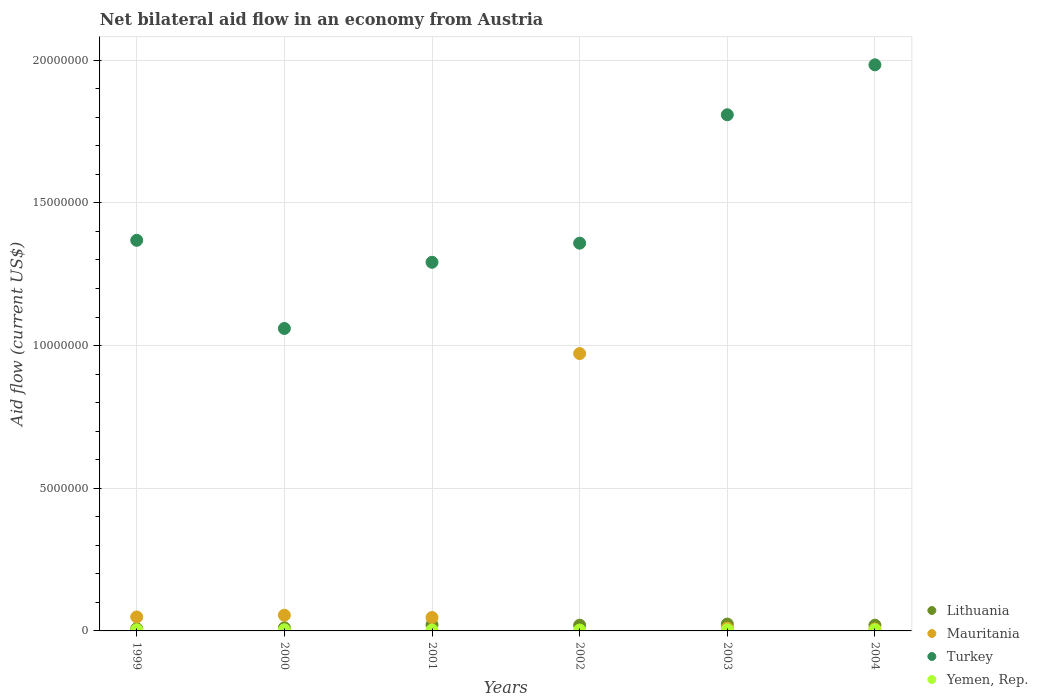How many different coloured dotlines are there?
Keep it short and to the point. 4. Is the number of dotlines equal to the number of legend labels?
Keep it short and to the point. Yes. What is the net bilateral aid flow in Mauritania in 2002?
Your answer should be compact. 9.72e+06. In which year was the net bilateral aid flow in Mauritania maximum?
Your answer should be very brief. 2002. What is the total net bilateral aid flow in Turkey in the graph?
Your answer should be compact. 8.87e+07. What is the difference between the net bilateral aid flow in Turkey in 2000 and that in 2004?
Make the answer very short. -9.24e+06. What is the difference between the net bilateral aid flow in Yemen, Rep. in 2002 and the net bilateral aid flow in Turkey in 1999?
Your answer should be compact. -1.37e+07. What is the average net bilateral aid flow in Turkey per year?
Ensure brevity in your answer.  1.48e+07. In the year 1999, what is the difference between the net bilateral aid flow in Lithuania and net bilateral aid flow in Yemen, Rep.?
Your answer should be compact. 4.00e+04. What is the ratio of the net bilateral aid flow in Turkey in 1999 to that in 2000?
Offer a very short reply. 1.29. Is the net bilateral aid flow in Yemen, Rep. in 1999 less than that in 2000?
Keep it short and to the point. No. What is the difference between the highest and the lowest net bilateral aid flow in Turkey?
Offer a very short reply. 9.24e+06. In how many years, is the net bilateral aid flow in Yemen, Rep. greater than the average net bilateral aid flow in Yemen, Rep. taken over all years?
Make the answer very short. 4. Is the sum of the net bilateral aid flow in Lithuania in 2002 and 2004 greater than the maximum net bilateral aid flow in Mauritania across all years?
Give a very brief answer. No. Is it the case that in every year, the sum of the net bilateral aid flow in Yemen, Rep. and net bilateral aid flow in Lithuania  is greater than the net bilateral aid flow in Mauritania?
Give a very brief answer. No. Does the net bilateral aid flow in Lithuania monotonically increase over the years?
Give a very brief answer. No. How many dotlines are there?
Offer a terse response. 4. Are the values on the major ticks of Y-axis written in scientific E-notation?
Offer a terse response. No. Where does the legend appear in the graph?
Offer a very short reply. Bottom right. How many legend labels are there?
Your answer should be compact. 4. How are the legend labels stacked?
Your answer should be compact. Vertical. What is the title of the graph?
Make the answer very short. Net bilateral aid flow in an economy from Austria. What is the label or title of the X-axis?
Provide a succinct answer. Years. What is the Aid flow (current US$) of Turkey in 1999?
Your answer should be very brief. 1.37e+07. What is the Aid flow (current US$) in Lithuania in 2000?
Ensure brevity in your answer.  1.10e+05. What is the Aid flow (current US$) in Mauritania in 2000?
Ensure brevity in your answer.  5.50e+05. What is the Aid flow (current US$) of Turkey in 2000?
Offer a very short reply. 1.06e+07. What is the Aid flow (current US$) of Yemen, Rep. in 2000?
Keep it short and to the point. 4.00e+04. What is the Aid flow (current US$) of Lithuania in 2001?
Your response must be concise. 2.20e+05. What is the Aid flow (current US$) of Mauritania in 2001?
Provide a succinct answer. 4.70e+05. What is the Aid flow (current US$) in Turkey in 2001?
Give a very brief answer. 1.29e+07. What is the Aid flow (current US$) in Mauritania in 2002?
Offer a terse response. 9.72e+06. What is the Aid flow (current US$) in Turkey in 2002?
Ensure brevity in your answer.  1.36e+07. What is the Aid flow (current US$) in Yemen, Rep. in 2002?
Provide a short and direct response. 3.00e+04. What is the Aid flow (current US$) of Lithuania in 2003?
Your response must be concise. 2.40e+05. What is the Aid flow (current US$) of Turkey in 2003?
Provide a short and direct response. 1.81e+07. What is the Aid flow (current US$) of Yemen, Rep. in 2003?
Give a very brief answer. 4.00e+04. What is the Aid flow (current US$) in Lithuania in 2004?
Your answer should be very brief. 2.00e+05. What is the Aid flow (current US$) in Mauritania in 2004?
Provide a short and direct response. 7.00e+04. What is the Aid flow (current US$) in Turkey in 2004?
Offer a very short reply. 1.98e+07. What is the Aid flow (current US$) in Yemen, Rep. in 2004?
Ensure brevity in your answer.  4.00e+04. Across all years, what is the maximum Aid flow (current US$) in Lithuania?
Make the answer very short. 2.40e+05. Across all years, what is the maximum Aid flow (current US$) in Mauritania?
Provide a succinct answer. 9.72e+06. Across all years, what is the maximum Aid flow (current US$) in Turkey?
Your answer should be compact. 1.98e+07. Across all years, what is the minimum Aid flow (current US$) of Mauritania?
Offer a terse response. 7.00e+04. Across all years, what is the minimum Aid flow (current US$) in Turkey?
Keep it short and to the point. 1.06e+07. Across all years, what is the minimum Aid flow (current US$) in Yemen, Rep.?
Provide a short and direct response. 3.00e+04. What is the total Aid flow (current US$) of Lithuania in the graph?
Keep it short and to the point. 1.05e+06. What is the total Aid flow (current US$) of Mauritania in the graph?
Your answer should be compact. 1.14e+07. What is the total Aid flow (current US$) of Turkey in the graph?
Provide a succinct answer. 8.87e+07. What is the total Aid flow (current US$) of Yemen, Rep. in the graph?
Provide a short and direct response. 2.20e+05. What is the difference between the Aid flow (current US$) of Mauritania in 1999 and that in 2000?
Make the answer very short. -6.00e+04. What is the difference between the Aid flow (current US$) in Turkey in 1999 and that in 2000?
Your response must be concise. 3.09e+06. What is the difference between the Aid flow (current US$) of Yemen, Rep. in 1999 and that in 2000?
Your answer should be very brief. 0. What is the difference between the Aid flow (current US$) in Mauritania in 1999 and that in 2001?
Give a very brief answer. 2.00e+04. What is the difference between the Aid flow (current US$) of Turkey in 1999 and that in 2001?
Offer a terse response. 7.70e+05. What is the difference between the Aid flow (current US$) in Mauritania in 1999 and that in 2002?
Provide a succinct answer. -9.23e+06. What is the difference between the Aid flow (current US$) in Mauritania in 1999 and that in 2003?
Give a very brief answer. 3.90e+05. What is the difference between the Aid flow (current US$) of Turkey in 1999 and that in 2003?
Give a very brief answer. -4.40e+06. What is the difference between the Aid flow (current US$) of Mauritania in 1999 and that in 2004?
Your answer should be compact. 4.20e+05. What is the difference between the Aid flow (current US$) of Turkey in 1999 and that in 2004?
Make the answer very short. -6.15e+06. What is the difference between the Aid flow (current US$) in Yemen, Rep. in 1999 and that in 2004?
Offer a terse response. 0. What is the difference between the Aid flow (current US$) in Lithuania in 2000 and that in 2001?
Give a very brief answer. -1.10e+05. What is the difference between the Aid flow (current US$) in Mauritania in 2000 and that in 2001?
Offer a very short reply. 8.00e+04. What is the difference between the Aid flow (current US$) of Turkey in 2000 and that in 2001?
Offer a very short reply. -2.32e+06. What is the difference between the Aid flow (current US$) of Lithuania in 2000 and that in 2002?
Keep it short and to the point. -9.00e+04. What is the difference between the Aid flow (current US$) in Mauritania in 2000 and that in 2002?
Your answer should be very brief. -9.17e+06. What is the difference between the Aid flow (current US$) in Turkey in 2000 and that in 2002?
Provide a short and direct response. -2.99e+06. What is the difference between the Aid flow (current US$) of Lithuania in 2000 and that in 2003?
Keep it short and to the point. -1.30e+05. What is the difference between the Aid flow (current US$) of Turkey in 2000 and that in 2003?
Provide a succinct answer. -7.49e+06. What is the difference between the Aid flow (current US$) in Yemen, Rep. in 2000 and that in 2003?
Provide a short and direct response. 0. What is the difference between the Aid flow (current US$) of Lithuania in 2000 and that in 2004?
Keep it short and to the point. -9.00e+04. What is the difference between the Aid flow (current US$) in Turkey in 2000 and that in 2004?
Provide a short and direct response. -9.24e+06. What is the difference between the Aid flow (current US$) in Yemen, Rep. in 2000 and that in 2004?
Keep it short and to the point. 0. What is the difference between the Aid flow (current US$) in Lithuania in 2001 and that in 2002?
Ensure brevity in your answer.  2.00e+04. What is the difference between the Aid flow (current US$) in Mauritania in 2001 and that in 2002?
Offer a very short reply. -9.25e+06. What is the difference between the Aid flow (current US$) in Turkey in 2001 and that in 2002?
Ensure brevity in your answer.  -6.70e+05. What is the difference between the Aid flow (current US$) of Lithuania in 2001 and that in 2003?
Your answer should be very brief. -2.00e+04. What is the difference between the Aid flow (current US$) in Mauritania in 2001 and that in 2003?
Keep it short and to the point. 3.70e+05. What is the difference between the Aid flow (current US$) of Turkey in 2001 and that in 2003?
Keep it short and to the point. -5.17e+06. What is the difference between the Aid flow (current US$) of Mauritania in 2001 and that in 2004?
Your answer should be compact. 4.00e+05. What is the difference between the Aid flow (current US$) of Turkey in 2001 and that in 2004?
Provide a short and direct response. -6.92e+06. What is the difference between the Aid flow (current US$) in Yemen, Rep. in 2001 and that in 2004?
Your response must be concise. -10000. What is the difference between the Aid flow (current US$) of Lithuania in 2002 and that in 2003?
Provide a succinct answer. -4.00e+04. What is the difference between the Aid flow (current US$) in Mauritania in 2002 and that in 2003?
Offer a very short reply. 9.62e+06. What is the difference between the Aid flow (current US$) in Turkey in 2002 and that in 2003?
Provide a short and direct response. -4.50e+06. What is the difference between the Aid flow (current US$) in Yemen, Rep. in 2002 and that in 2003?
Give a very brief answer. -10000. What is the difference between the Aid flow (current US$) in Lithuania in 2002 and that in 2004?
Offer a terse response. 0. What is the difference between the Aid flow (current US$) in Mauritania in 2002 and that in 2004?
Offer a very short reply. 9.65e+06. What is the difference between the Aid flow (current US$) in Turkey in 2002 and that in 2004?
Your answer should be compact. -6.25e+06. What is the difference between the Aid flow (current US$) in Yemen, Rep. in 2002 and that in 2004?
Your response must be concise. -10000. What is the difference between the Aid flow (current US$) in Turkey in 2003 and that in 2004?
Give a very brief answer. -1.75e+06. What is the difference between the Aid flow (current US$) of Yemen, Rep. in 2003 and that in 2004?
Offer a terse response. 0. What is the difference between the Aid flow (current US$) of Lithuania in 1999 and the Aid flow (current US$) of Mauritania in 2000?
Ensure brevity in your answer.  -4.70e+05. What is the difference between the Aid flow (current US$) of Lithuania in 1999 and the Aid flow (current US$) of Turkey in 2000?
Your answer should be compact. -1.05e+07. What is the difference between the Aid flow (current US$) of Mauritania in 1999 and the Aid flow (current US$) of Turkey in 2000?
Offer a terse response. -1.01e+07. What is the difference between the Aid flow (current US$) of Mauritania in 1999 and the Aid flow (current US$) of Yemen, Rep. in 2000?
Make the answer very short. 4.50e+05. What is the difference between the Aid flow (current US$) of Turkey in 1999 and the Aid flow (current US$) of Yemen, Rep. in 2000?
Give a very brief answer. 1.36e+07. What is the difference between the Aid flow (current US$) of Lithuania in 1999 and the Aid flow (current US$) of Mauritania in 2001?
Your response must be concise. -3.90e+05. What is the difference between the Aid flow (current US$) of Lithuania in 1999 and the Aid flow (current US$) of Turkey in 2001?
Ensure brevity in your answer.  -1.28e+07. What is the difference between the Aid flow (current US$) of Mauritania in 1999 and the Aid flow (current US$) of Turkey in 2001?
Make the answer very short. -1.24e+07. What is the difference between the Aid flow (current US$) of Mauritania in 1999 and the Aid flow (current US$) of Yemen, Rep. in 2001?
Ensure brevity in your answer.  4.60e+05. What is the difference between the Aid flow (current US$) of Turkey in 1999 and the Aid flow (current US$) of Yemen, Rep. in 2001?
Make the answer very short. 1.37e+07. What is the difference between the Aid flow (current US$) of Lithuania in 1999 and the Aid flow (current US$) of Mauritania in 2002?
Ensure brevity in your answer.  -9.64e+06. What is the difference between the Aid flow (current US$) of Lithuania in 1999 and the Aid flow (current US$) of Turkey in 2002?
Give a very brief answer. -1.35e+07. What is the difference between the Aid flow (current US$) in Mauritania in 1999 and the Aid flow (current US$) in Turkey in 2002?
Your answer should be very brief. -1.31e+07. What is the difference between the Aid flow (current US$) of Mauritania in 1999 and the Aid flow (current US$) of Yemen, Rep. in 2002?
Offer a terse response. 4.60e+05. What is the difference between the Aid flow (current US$) of Turkey in 1999 and the Aid flow (current US$) of Yemen, Rep. in 2002?
Ensure brevity in your answer.  1.37e+07. What is the difference between the Aid flow (current US$) in Lithuania in 1999 and the Aid flow (current US$) in Turkey in 2003?
Offer a terse response. -1.80e+07. What is the difference between the Aid flow (current US$) in Lithuania in 1999 and the Aid flow (current US$) in Yemen, Rep. in 2003?
Your response must be concise. 4.00e+04. What is the difference between the Aid flow (current US$) of Mauritania in 1999 and the Aid flow (current US$) of Turkey in 2003?
Your answer should be very brief. -1.76e+07. What is the difference between the Aid flow (current US$) of Turkey in 1999 and the Aid flow (current US$) of Yemen, Rep. in 2003?
Keep it short and to the point. 1.36e+07. What is the difference between the Aid flow (current US$) in Lithuania in 1999 and the Aid flow (current US$) in Mauritania in 2004?
Give a very brief answer. 10000. What is the difference between the Aid flow (current US$) in Lithuania in 1999 and the Aid flow (current US$) in Turkey in 2004?
Ensure brevity in your answer.  -1.98e+07. What is the difference between the Aid flow (current US$) of Mauritania in 1999 and the Aid flow (current US$) of Turkey in 2004?
Provide a succinct answer. -1.94e+07. What is the difference between the Aid flow (current US$) of Mauritania in 1999 and the Aid flow (current US$) of Yemen, Rep. in 2004?
Your response must be concise. 4.50e+05. What is the difference between the Aid flow (current US$) in Turkey in 1999 and the Aid flow (current US$) in Yemen, Rep. in 2004?
Your answer should be compact. 1.36e+07. What is the difference between the Aid flow (current US$) of Lithuania in 2000 and the Aid flow (current US$) of Mauritania in 2001?
Offer a very short reply. -3.60e+05. What is the difference between the Aid flow (current US$) of Lithuania in 2000 and the Aid flow (current US$) of Turkey in 2001?
Ensure brevity in your answer.  -1.28e+07. What is the difference between the Aid flow (current US$) in Mauritania in 2000 and the Aid flow (current US$) in Turkey in 2001?
Your answer should be very brief. -1.24e+07. What is the difference between the Aid flow (current US$) of Mauritania in 2000 and the Aid flow (current US$) of Yemen, Rep. in 2001?
Keep it short and to the point. 5.20e+05. What is the difference between the Aid flow (current US$) of Turkey in 2000 and the Aid flow (current US$) of Yemen, Rep. in 2001?
Offer a terse response. 1.06e+07. What is the difference between the Aid flow (current US$) of Lithuania in 2000 and the Aid flow (current US$) of Mauritania in 2002?
Your answer should be very brief. -9.61e+06. What is the difference between the Aid flow (current US$) of Lithuania in 2000 and the Aid flow (current US$) of Turkey in 2002?
Provide a short and direct response. -1.35e+07. What is the difference between the Aid flow (current US$) in Mauritania in 2000 and the Aid flow (current US$) in Turkey in 2002?
Offer a very short reply. -1.30e+07. What is the difference between the Aid flow (current US$) in Mauritania in 2000 and the Aid flow (current US$) in Yemen, Rep. in 2002?
Keep it short and to the point. 5.20e+05. What is the difference between the Aid flow (current US$) in Turkey in 2000 and the Aid flow (current US$) in Yemen, Rep. in 2002?
Make the answer very short. 1.06e+07. What is the difference between the Aid flow (current US$) of Lithuania in 2000 and the Aid flow (current US$) of Mauritania in 2003?
Your answer should be compact. 10000. What is the difference between the Aid flow (current US$) of Lithuania in 2000 and the Aid flow (current US$) of Turkey in 2003?
Make the answer very short. -1.80e+07. What is the difference between the Aid flow (current US$) of Lithuania in 2000 and the Aid flow (current US$) of Yemen, Rep. in 2003?
Your answer should be very brief. 7.00e+04. What is the difference between the Aid flow (current US$) of Mauritania in 2000 and the Aid flow (current US$) of Turkey in 2003?
Offer a terse response. -1.75e+07. What is the difference between the Aid flow (current US$) of Mauritania in 2000 and the Aid flow (current US$) of Yemen, Rep. in 2003?
Make the answer very short. 5.10e+05. What is the difference between the Aid flow (current US$) in Turkey in 2000 and the Aid flow (current US$) in Yemen, Rep. in 2003?
Provide a succinct answer. 1.06e+07. What is the difference between the Aid flow (current US$) in Lithuania in 2000 and the Aid flow (current US$) in Turkey in 2004?
Your response must be concise. -1.97e+07. What is the difference between the Aid flow (current US$) in Lithuania in 2000 and the Aid flow (current US$) in Yemen, Rep. in 2004?
Keep it short and to the point. 7.00e+04. What is the difference between the Aid flow (current US$) in Mauritania in 2000 and the Aid flow (current US$) in Turkey in 2004?
Your response must be concise. -1.93e+07. What is the difference between the Aid flow (current US$) in Mauritania in 2000 and the Aid flow (current US$) in Yemen, Rep. in 2004?
Ensure brevity in your answer.  5.10e+05. What is the difference between the Aid flow (current US$) in Turkey in 2000 and the Aid flow (current US$) in Yemen, Rep. in 2004?
Your response must be concise. 1.06e+07. What is the difference between the Aid flow (current US$) in Lithuania in 2001 and the Aid flow (current US$) in Mauritania in 2002?
Your answer should be very brief. -9.50e+06. What is the difference between the Aid flow (current US$) in Lithuania in 2001 and the Aid flow (current US$) in Turkey in 2002?
Ensure brevity in your answer.  -1.34e+07. What is the difference between the Aid flow (current US$) of Mauritania in 2001 and the Aid flow (current US$) of Turkey in 2002?
Offer a terse response. -1.31e+07. What is the difference between the Aid flow (current US$) of Turkey in 2001 and the Aid flow (current US$) of Yemen, Rep. in 2002?
Your answer should be very brief. 1.29e+07. What is the difference between the Aid flow (current US$) of Lithuania in 2001 and the Aid flow (current US$) of Turkey in 2003?
Keep it short and to the point. -1.79e+07. What is the difference between the Aid flow (current US$) in Mauritania in 2001 and the Aid flow (current US$) in Turkey in 2003?
Offer a terse response. -1.76e+07. What is the difference between the Aid flow (current US$) in Mauritania in 2001 and the Aid flow (current US$) in Yemen, Rep. in 2003?
Your answer should be very brief. 4.30e+05. What is the difference between the Aid flow (current US$) in Turkey in 2001 and the Aid flow (current US$) in Yemen, Rep. in 2003?
Your answer should be compact. 1.29e+07. What is the difference between the Aid flow (current US$) in Lithuania in 2001 and the Aid flow (current US$) in Turkey in 2004?
Keep it short and to the point. -1.96e+07. What is the difference between the Aid flow (current US$) of Lithuania in 2001 and the Aid flow (current US$) of Yemen, Rep. in 2004?
Provide a succinct answer. 1.80e+05. What is the difference between the Aid flow (current US$) in Mauritania in 2001 and the Aid flow (current US$) in Turkey in 2004?
Offer a terse response. -1.94e+07. What is the difference between the Aid flow (current US$) of Mauritania in 2001 and the Aid flow (current US$) of Yemen, Rep. in 2004?
Your answer should be compact. 4.30e+05. What is the difference between the Aid flow (current US$) in Turkey in 2001 and the Aid flow (current US$) in Yemen, Rep. in 2004?
Offer a very short reply. 1.29e+07. What is the difference between the Aid flow (current US$) in Lithuania in 2002 and the Aid flow (current US$) in Mauritania in 2003?
Make the answer very short. 1.00e+05. What is the difference between the Aid flow (current US$) in Lithuania in 2002 and the Aid flow (current US$) in Turkey in 2003?
Your answer should be compact. -1.79e+07. What is the difference between the Aid flow (current US$) of Mauritania in 2002 and the Aid flow (current US$) of Turkey in 2003?
Ensure brevity in your answer.  -8.37e+06. What is the difference between the Aid flow (current US$) in Mauritania in 2002 and the Aid flow (current US$) in Yemen, Rep. in 2003?
Make the answer very short. 9.68e+06. What is the difference between the Aid flow (current US$) of Turkey in 2002 and the Aid flow (current US$) of Yemen, Rep. in 2003?
Keep it short and to the point. 1.36e+07. What is the difference between the Aid flow (current US$) in Lithuania in 2002 and the Aid flow (current US$) in Turkey in 2004?
Your response must be concise. -1.96e+07. What is the difference between the Aid flow (current US$) in Lithuania in 2002 and the Aid flow (current US$) in Yemen, Rep. in 2004?
Your answer should be very brief. 1.60e+05. What is the difference between the Aid flow (current US$) of Mauritania in 2002 and the Aid flow (current US$) of Turkey in 2004?
Your answer should be compact. -1.01e+07. What is the difference between the Aid flow (current US$) of Mauritania in 2002 and the Aid flow (current US$) of Yemen, Rep. in 2004?
Ensure brevity in your answer.  9.68e+06. What is the difference between the Aid flow (current US$) of Turkey in 2002 and the Aid flow (current US$) of Yemen, Rep. in 2004?
Keep it short and to the point. 1.36e+07. What is the difference between the Aid flow (current US$) in Lithuania in 2003 and the Aid flow (current US$) in Mauritania in 2004?
Provide a succinct answer. 1.70e+05. What is the difference between the Aid flow (current US$) of Lithuania in 2003 and the Aid flow (current US$) of Turkey in 2004?
Your answer should be very brief. -1.96e+07. What is the difference between the Aid flow (current US$) in Lithuania in 2003 and the Aid flow (current US$) in Yemen, Rep. in 2004?
Your response must be concise. 2.00e+05. What is the difference between the Aid flow (current US$) of Mauritania in 2003 and the Aid flow (current US$) of Turkey in 2004?
Make the answer very short. -1.97e+07. What is the difference between the Aid flow (current US$) in Mauritania in 2003 and the Aid flow (current US$) in Yemen, Rep. in 2004?
Give a very brief answer. 6.00e+04. What is the difference between the Aid flow (current US$) of Turkey in 2003 and the Aid flow (current US$) of Yemen, Rep. in 2004?
Give a very brief answer. 1.80e+07. What is the average Aid flow (current US$) in Lithuania per year?
Your answer should be very brief. 1.75e+05. What is the average Aid flow (current US$) of Mauritania per year?
Offer a very short reply. 1.90e+06. What is the average Aid flow (current US$) of Turkey per year?
Offer a very short reply. 1.48e+07. What is the average Aid flow (current US$) in Yemen, Rep. per year?
Offer a very short reply. 3.67e+04. In the year 1999, what is the difference between the Aid flow (current US$) in Lithuania and Aid flow (current US$) in Mauritania?
Offer a very short reply. -4.10e+05. In the year 1999, what is the difference between the Aid flow (current US$) of Lithuania and Aid flow (current US$) of Turkey?
Make the answer very short. -1.36e+07. In the year 1999, what is the difference between the Aid flow (current US$) of Lithuania and Aid flow (current US$) of Yemen, Rep.?
Make the answer very short. 4.00e+04. In the year 1999, what is the difference between the Aid flow (current US$) in Mauritania and Aid flow (current US$) in Turkey?
Provide a succinct answer. -1.32e+07. In the year 1999, what is the difference between the Aid flow (current US$) of Turkey and Aid flow (current US$) of Yemen, Rep.?
Provide a succinct answer. 1.36e+07. In the year 2000, what is the difference between the Aid flow (current US$) of Lithuania and Aid flow (current US$) of Mauritania?
Offer a terse response. -4.40e+05. In the year 2000, what is the difference between the Aid flow (current US$) of Lithuania and Aid flow (current US$) of Turkey?
Your answer should be very brief. -1.05e+07. In the year 2000, what is the difference between the Aid flow (current US$) of Lithuania and Aid flow (current US$) of Yemen, Rep.?
Give a very brief answer. 7.00e+04. In the year 2000, what is the difference between the Aid flow (current US$) in Mauritania and Aid flow (current US$) in Turkey?
Ensure brevity in your answer.  -1.00e+07. In the year 2000, what is the difference between the Aid flow (current US$) of Mauritania and Aid flow (current US$) of Yemen, Rep.?
Offer a very short reply. 5.10e+05. In the year 2000, what is the difference between the Aid flow (current US$) of Turkey and Aid flow (current US$) of Yemen, Rep.?
Give a very brief answer. 1.06e+07. In the year 2001, what is the difference between the Aid flow (current US$) in Lithuania and Aid flow (current US$) in Mauritania?
Your answer should be compact. -2.50e+05. In the year 2001, what is the difference between the Aid flow (current US$) of Lithuania and Aid flow (current US$) of Turkey?
Provide a short and direct response. -1.27e+07. In the year 2001, what is the difference between the Aid flow (current US$) of Mauritania and Aid flow (current US$) of Turkey?
Offer a very short reply. -1.24e+07. In the year 2001, what is the difference between the Aid flow (current US$) in Turkey and Aid flow (current US$) in Yemen, Rep.?
Your answer should be very brief. 1.29e+07. In the year 2002, what is the difference between the Aid flow (current US$) of Lithuania and Aid flow (current US$) of Mauritania?
Your answer should be compact. -9.52e+06. In the year 2002, what is the difference between the Aid flow (current US$) in Lithuania and Aid flow (current US$) in Turkey?
Keep it short and to the point. -1.34e+07. In the year 2002, what is the difference between the Aid flow (current US$) in Lithuania and Aid flow (current US$) in Yemen, Rep.?
Provide a succinct answer. 1.70e+05. In the year 2002, what is the difference between the Aid flow (current US$) in Mauritania and Aid flow (current US$) in Turkey?
Your answer should be compact. -3.87e+06. In the year 2002, what is the difference between the Aid flow (current US$) of Mauritania and Aid flow (current US$) of Yemen, Rep.?
Provide a short and direct response. 9.69e+06. In the year 2002, what is the difference between the Aid flow (current US$) in Turkey and Aid flow (current US$) in Yemen, Rep.?
Give a very brief answer. 1.36e+07. In the year 2003, what is the difference between the Aid flow (current US$) in Lithuania and Aid flow (current US$) in Turkey?
Make the answer very short. -1.78e+07. In the year 2003, what is the difference between the Aid flow (current US$) of Lithuania and Aid flow (current US$) of Yemen, Rep.?
Offer a terse response. 2.00e+05. In the year 2003, what is the difference between the Aid flow (current US$) in Mauritania and Aid flow (current US$) in Turkey?
Your answer should be compact. -1.80e+07. In the year 2003, what is the difference between the Aid flow (current US$) in Turkey and Aid flow (current US$) in Yemen, Rep.?
Make the answer very short. 1.80e+07. In the year 2004, what is the difference between the Aid flow (current US$) of Lithuania and Aid flow (current US$) of Turkey?
Ensure brevity in your answer.  -1.96e+07. In the year 2004, what is the difference between the Aid flow (current US$) of Lithuania and Aid flow (current US$) of Yemen, Rep.?
Offer a very short reply. 1.60e+05. In the year 2004, what is the difference between the Aid flow (current US$) in Mauritania and Aid flow (current US$) in Turkey?
Give a very brief answer. -1.98e+07. In the year 2004, what is the difference between the Aid flow (current US$) in Mauritania and Aid flow (current US$) in Yemen, Rep.?
Your response must be concise. 3.00e+04. In the year 2004, what is the difference between the Aid flow (current US$) of Turkey and Aid flow (current US$) of Yemen, Rep.?
Ensure brevity in your answer.  1.98e+07. What is the ratio of the Aid flow (current US$) in Lithuania in 1999 to that in 2000?
Give a very brief answer. 0.73. What is the ratio of the Aid flow (current US$) of Mauritania in 1999 to that in 2000?
Your answer should be very brief. 0.89. What is the ratio of the Aid flow (current US$) in Turkey in 1999 to that in 2000?
Your answer should be compact. 1.29. What is the ratio of the Aid flow (current US$) in Yemen, Rep. in 1999 to that in 2000?
Offer a terse response. 1. What is the ratio of the Aid flow (current US$) in Lithuania in 1999 to that in 2001?
Offer a very short reply. 0.36. What is the ratio of the Aid flow (current US$) in Mauritania in 1999 to that in 2001?
Provide a short and direct response. 1.04. What is the ratio of the Aid flow (current US$) in Turkey in 1999 to that in 2001?
Provide a succinct answer. 1.06. What is the ratio of the Aid flow (current US$) of Yemen, Rep. in 1999 to that in 2001?
Your response must be concise. 1.33. What is the ratio of the Aid flow (current US$) in Lithuania in 1999 to that in 2002?
Provide a short and direct response. 0.4. What is the ratio of the Aid flow (current US$) in Mauritania in 1999 to that in 2002?
Provide a succinct answer. 0.05. What is the ratio of the Aid flow (current US$) of Turkey in 1999 to that in 2002?
Keep it short and to the point. 1.01. What is the ratio of the Aid flow (current US$) of Turkey in 1999 to that in 2003?
Keep it short and to the point. 0.76. What is the ratio of the Aid flow (current US$) in Yemen, Rep. in 1999 to that in 2003?
Your response must be concise. 1. What is the ratio of the Aid flow (current US$) of Lithuania in 1999 to that in 2004?
Your answer should be compact. 0.4. What is the ratio of the Aid flow (current US$) in Mauritania in 1999 to that in 2004?
Your response must be concise. 7. What is the ratio of the Aid flow (current US$) in Turkey in 1999 to that in 2004?
Ensure brevity in your answer.  0.69. What is the ratio of the Aid flow (current US$) of Yemen, Rep. in 1999 to that in 2004?
Make the answer very short. 1. What is the ratio of the Aid flow (current US$) in Lithuania in 2000 to that in 2001?
Offer a terse response. 0.5. What is the ratio of the Aid flow (current US$) in Mauritania in 2000 to that in 2001?
Keep it short and to the point. 1.17. What is the ratio of the Aid flow (current US$) in Turkey in 2000 to that in 2001?
Your answer should be very brief. 0.82. What is the ratio of the Aid flow (current US$) of Lithuania in 2000 to that in 2002?
Offer a very short reply. 0.55. What is the ratio of the Aid flow (current US$) of Mauritania in 2000 to that in 2002?
Give a very brief answer. 0.06. What is the ratio of the Aid flow (current US$) in Turkey in 2000 to that in 2002?
Offer a very short reply. 0.78. What is the ratio of the Aid flow (current US$) of Lithuania in 2000 to that in 2003?
Make the answer very short. 0.46. What is the ratio of the Aid flow (current US$) in Mauritania in 2000 to that in 2003?
Give a very brief answer. 5.5. What is the ratio of the Aid flow (current US$) of Turkey in 2000 to that in 2003?
Your answer should be compact. 0.59. What is the ratio of the Aid flow (current US$) in Yemen, Rep. in 2000 to that in 2003?
Provide a succinct answer. 1. What is the ratio of the Aid flow (current US$) of Lithuania in 2000 to that in 2004?
Provide a succinct answer. 0.55. What is the ratio of the Aid flow (current US$) in Mauritania in 2000 to that in 2004?
Your response must be concise. 7.86. What is the ratio of the Aid flow (current US$) of Turkey in 2000 to that in 2004?
Make the answer very short. 0.53. What is the ratio of the Aid flow (current US$) of Lithuania in 2001 to that in 2002?
Provide a short and direct response. 1.1. What is the ratio of the Aid flow (current US$) of Mauritania in 2001 to that in 2002?
Your response must be concise. 0.05. What is the ratio of the Aid flow (current US$) in Turkey in 2001 to that in 2002?
Offer a very short reply. 0.95. What is the ratio of the Aid flow (current US$) of Yemen, Rep. in 2001 to that in 2002?
Give a very brief answer. 1. What is the ratio of the Aid flow (current US$) in Lithuania in 2001 to that in 2003?
Your response must be concise. 0.92. What is the ratio of the Aid flow (current US$) of Turkey in 2001 to that in 2003?
Give a very brief answer. 0.71. What is the ratio of the Aid flow (current US$) of Yemen, Rep. in 2001 to that in 2003?
Give a very brief answer. 0.75. What is the ratio of the Aid flow (current US$) in Lithuania in 2001 to that in 2004?
Make the answer very short. 1.1. What is the ratio of the Aid flow (current US$) in Mauritania in 2001 to that in 2004?
Give a very brief answer. 6.71. What is the ratio of the Aid flow (current US$) of Turkey in 2001 to that in 2004?
Give a very brief answer. 0.65. What is the ratio of the Aid flow (current US$) in Mauritania in 2002 to that in 2003?
Your answer should be very brief. 97.2. What is the ratio of the Aid flow (current US$) in Turkey in 2002 to that in 2003?
Your answer should be very brief. 0.75. What is the ratio of the Aid flow (current US$) in Yemen, Rep. in 2002 to that in 2003?
Keep it short and to the point. 0.75. What is the ratio of the Aid flow (current US$) of Lithuania in 2002 to that in 2004?
Offer a very short reply. 1. What is the ratio of the Aid flow (current US$) in Mauritania in 2002 to that in 2004?
Keep it short and to the point. 138.86. What is the ratio of the Aid flow (current US$) of Turkey in 2002 to that in 2004?
Offer a terse response. 0.69. What is the ratio of the Aid flow (current US$) in Yemen, Rep. in 2002 to that in 2004?
Your answer should be very brief. 0.75. What is the ratio of the Aid flow (current US$) in Lithuania in 2003 to that in 2004?
Your answer should be very brief. 1.2. What is the ratio of the Aid flow (current US$) in Mauritania in 2003 to that in 2004?
Offer a very short reply. 1.43. What is the ratio of the Aid flow (current US$) in Turkey in 2003 to that in 2004?
Your answer should be very brief. 0.91. What is the ratio of the Aid flow (current US$) of Yemen, Rep. in 2003 to that in 2004?
Make the answer very short. 1. What is the difference between the highest and the second highest Aid flow (current US$) of Lithuania?
Ensure brevity in your answer.  2.00e+04. What is the difference between the highest and the second highest Aid flow (current US$) in Mauritania?
Keep it short and to the point. 9.17e+06. What is the difference between the highest and the second highest Aid flow (current US$) of Turkey?
Your answer should be compact. 1.75e+06. What is the difference between the highest and the lowest Aid flow (current US$) in Lithuania?
Provide a short and direct response. 1.60e+05. What is the difference between the highest and the lowest Aid flow (current US$) in Mauritania?
Ensure brevity in your answer.  9.65e+06. What is the difference between the highest and the lowest Aid flow (current US$) of Turkey?
Offer a very short reply. 9.24e+06. 